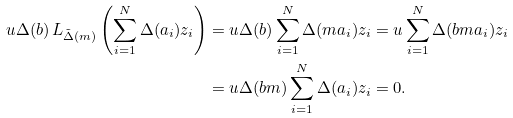Convert formula to latex. <formula><loc_0><loc_0><loc_500><loc_500>u \Delta ( b ) \, L _ { \tilde { \Delta } ( m ) } \left ( \sum _ { i = 1 } ^ { N } \Delta ( a _ { i } ) z _ { i } \right ) & = u \Delta ( b ) \sum _ { i = 1 } ^ { N } \Delta ( m a _ { i } ) z _ { i } = u \sum _ { i = 1 } ^ { N } \Delta ( b m a _ { i } ) z _ { i } \\ & = u \Delta ( b m ) \sum _ { i = 1 } ^ { N } \Delta ( a _ { i } ) z _ { i } = 0 .</formula> 